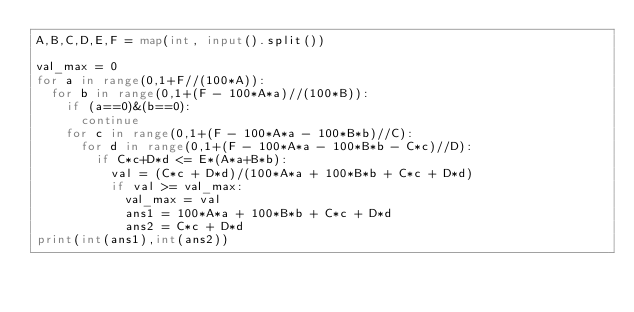<code> <loc_0><loc_0><loc_500><loc_500><_Python_>A,B,C,D,E,F = map(int, input().split())

val_max = 0
for a in range(0,1+F//(100*A)):
  for b in range(0,1+(F - 100*A*a)//(100*B)):
    if (a==0)&(b==0):
      continue
    for c in range(0,1+(F - 100*A*a - 100*B*b)//C):
      for d in range(0,1+(F - 100*A*a - 100*B*b - C*c)//D):
        if C*c+D*d <= E*(A*a+B*b):
          val = (C*c + D*d)/(100*A*a + 100*B*b + C*c + D*d)
          if val >= val_max:
            val_max = val
            ans1 = 100*A*a + 100*B*b + C*c + D*d
            ans2 = C*c + D*d
print(int(ans1),int(ans2))
</code> 